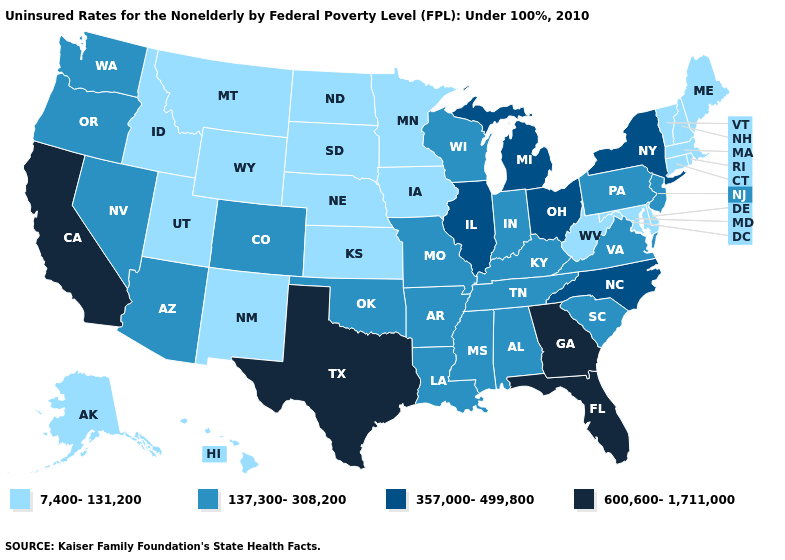Which states hav the highest value in the South?
Keep it brief. Florida, Georgia, Texas. What is the value of Nevada?
Write a very short answer. 137,300-308,200. What is the highest value in the USA?
Keep it brief. 600,600-1,711,000. Name the states that have a value in the range 7,400-131,200?
Concise answer only. Alaska, Connecticut, Delaware, Hawaii, Idaho, Iowa, Kansas, Maine, Maryland, Massachusetts, Minnesota, Montana, Nebraska, New Hampshire, New Mexico, North Dakota, Rhode Island, South Dakota, Utah, Vermont, West Virginia, Wyoming. Does Georgia have a higher value than Mississippi?
Give a very brief answer. Yes. Among the states that border Wisconsin , does Illinois have the highest value?
Short answer required. Yes. What is the highest value in states that border Arizona?
Give a very brief answer. 600,600-1,711,000. Which states hav the highest value in the West?
Be succinct. California. Which states hav the highest value in the South?
Answer briefly. Florida, Georgia, Texas. What is the value of Wisconsin?
Quick response, please. 137,300-308,200. Name the states that have a value in the range 357,000-499,800?
Short answer required. Illinois, Michigan, New York, North Carolina, Ohio. What is the value of Maine?
Concise answer only. 7,400-131,200. Does the map have missing data?
Be succinct. No. Does West Virginia have the lowest value in the South?
Concise answer only. Yes. What is the value of Utah?
Give a very brief answer. 7,400-131,200. 